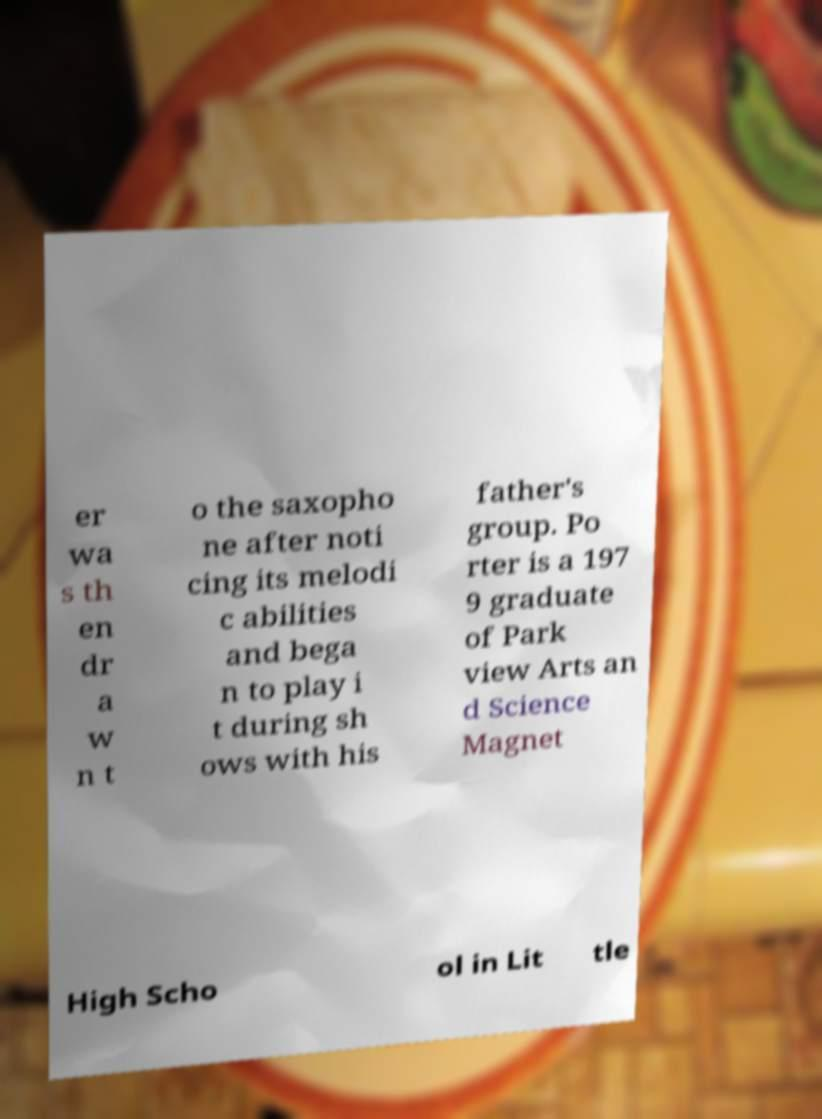Please read and relay the text visible in this image. What does it say? er wa s th en dr a w n t o the saxopho ne after noti cing its melodi c abilities and bega n to play i t during sh ows with his father's group. Po rter is a 197 9 graduate of Park view Arts an d Science Magnet High Scho ol in Lit tle 